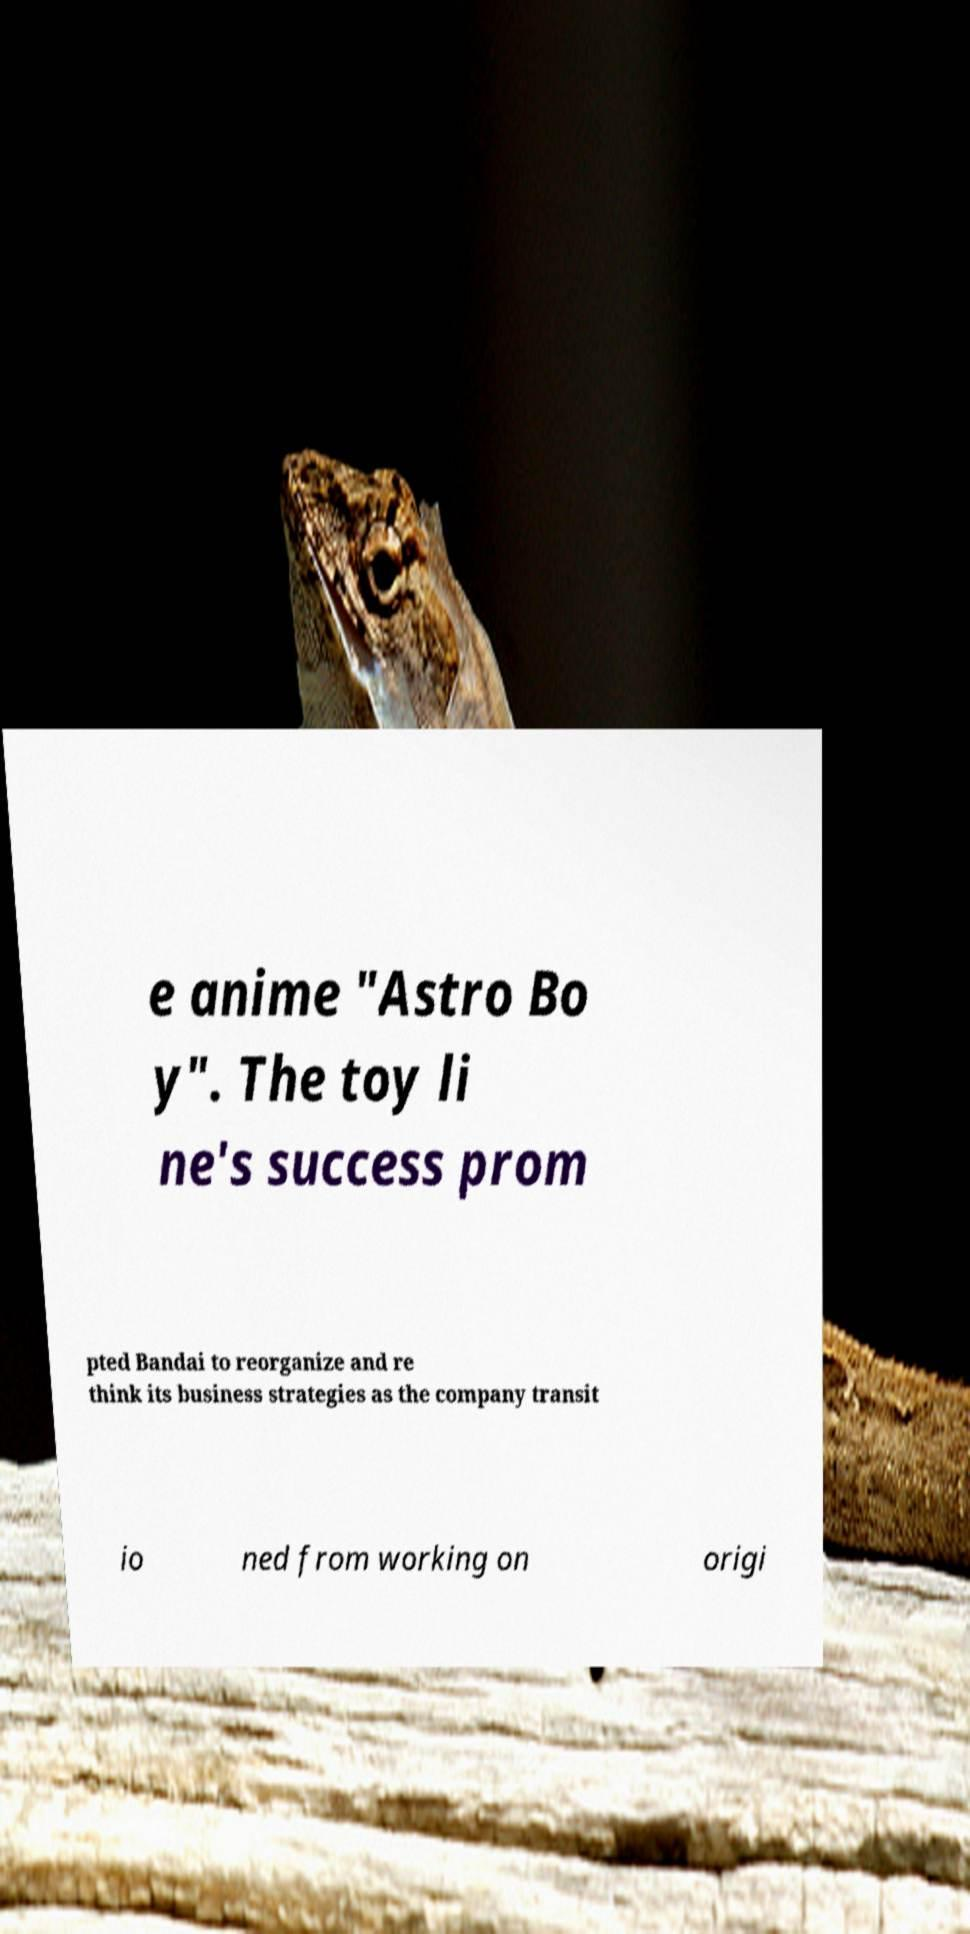Can you accurately transcribe the text from the provided image for me? e anime "Astro Bo y". The toy li ne's success prom pted Bandai to reorganize and re think its business strategies as the company transit io ned from working on origi 